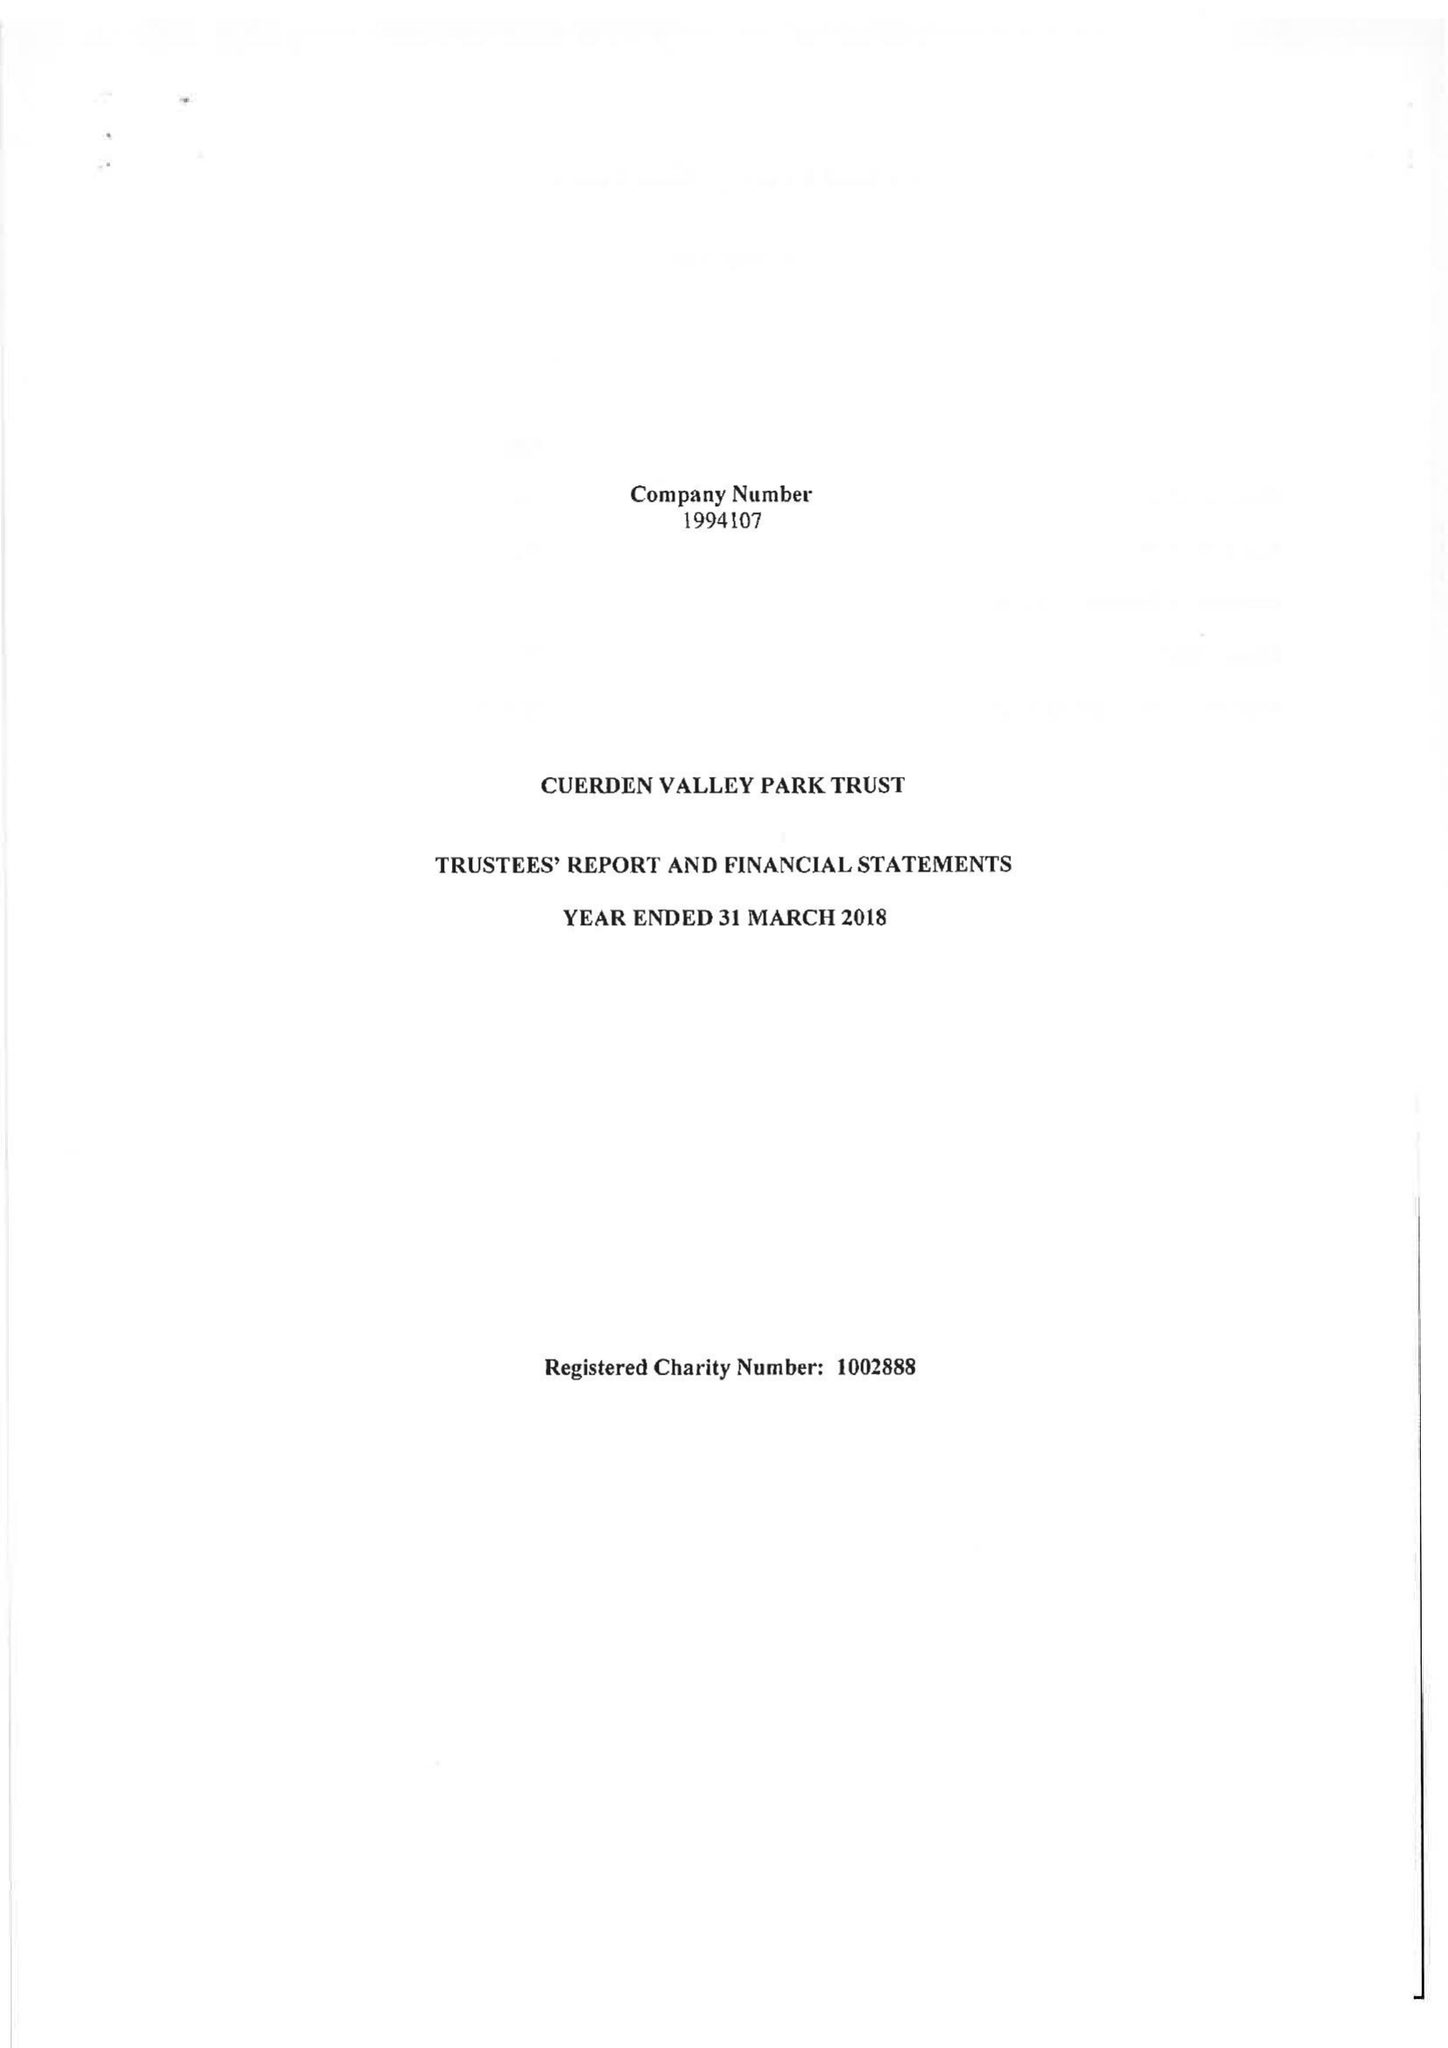What is the value for the address__postcode?
Answer the question using a single word or phrase. PR5 6BY 